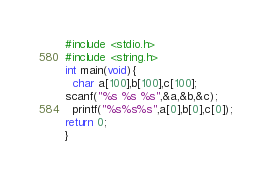<code> <loc_0><loc_0><loc_500><loc_500><_C_>#include <stdio.h>
#include <string.h>
int main(void){
  char a[100],b[100],c[100];
scanf("%s %s %s",&a,&b,&c);
  printf("%s%s%s",a[0],b[0],c[0]);
return 0;
}</code> 